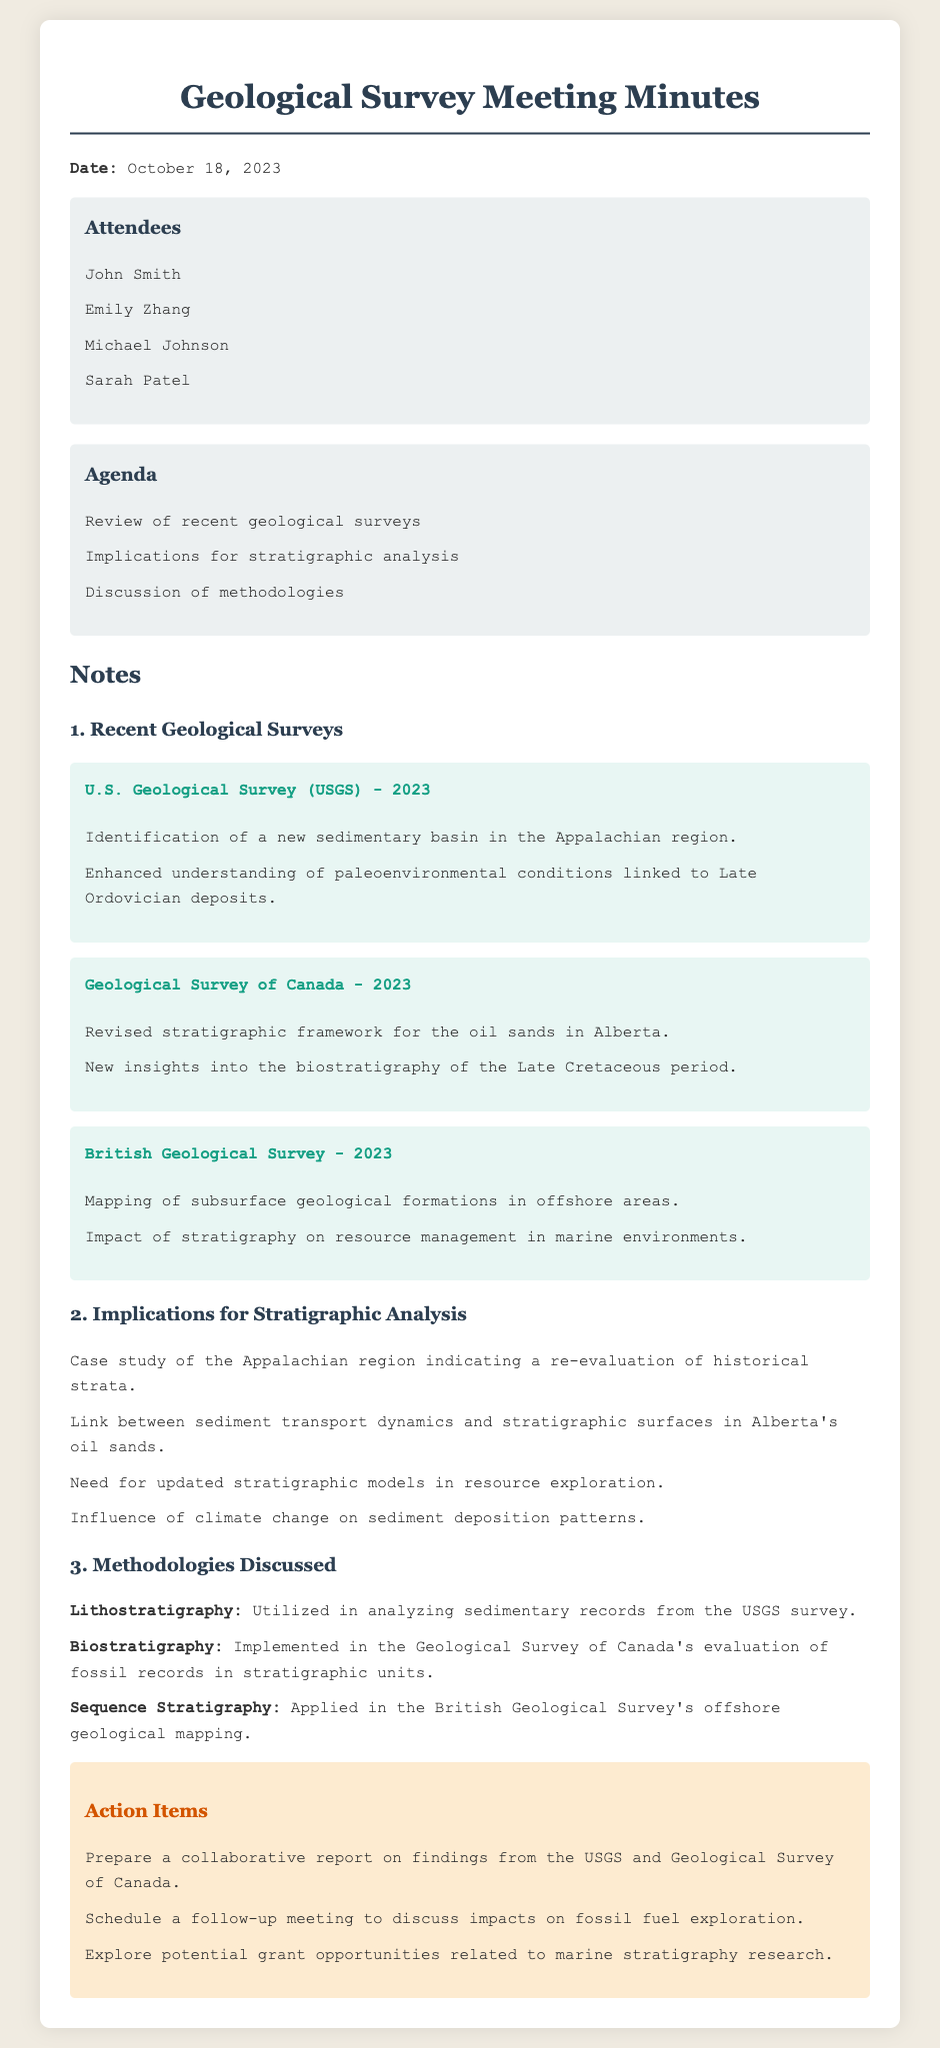What is the date of the meeting? The date of the meeting is specified at the beginning of the document.
Answer: October 18, 2023 Who conducted the geological survey in the Appalachian region? The document lists the U.S. Geological Survey as the organization responsible for the survey in this region.
Answer: U.S. Geological Survey What new geological feature was identified by the USGS? The document notes the identification of a new sedimentary basin as part of the USGS findings.
Answer: Sedimentary basin Which stratigraphic methodology was used in the USGS survey? The document specifically mentions lithostratigraphy as the methodology utilized in the USGS survey.
Answer: Lithostratigraphy What does the case study of the Appalachian region indicate? The document provides a summary of the case study and its implications, stating it prompts a re-evaluation of historical strata.
Answer: Re-evaluation of historical strata How many attendees are listed in the document? The document enumerates the attendees at the meeting.
Answer: Four What was one of the action items from the meeting? The document specifies several action items agreed upon during the meeting.
Answer: Prepare a collaborative report on findings from the USGS and Geological Survey of Canada Which geological survey focused on the oil sands in Alberta? The document refers specifically to the Geological Survey of Canada’s work related to the oil sands.
Answer: Geological Survey of Canada 